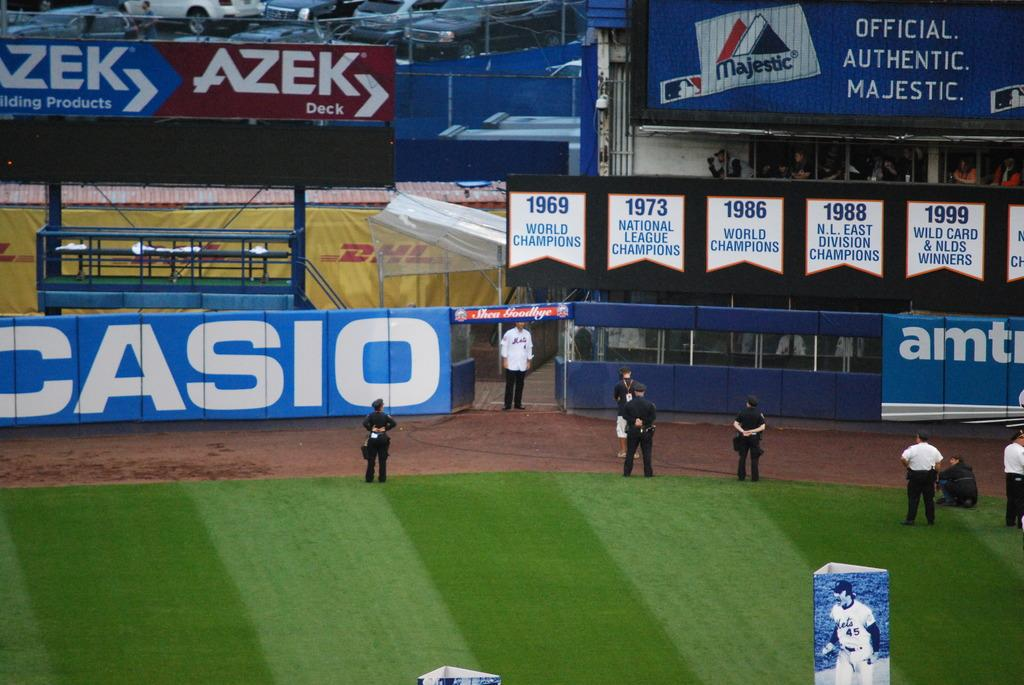<image>
Share a concise interpretation of the image provided. 7 people stand on a baseball field with billboards for casio and azek in the background 